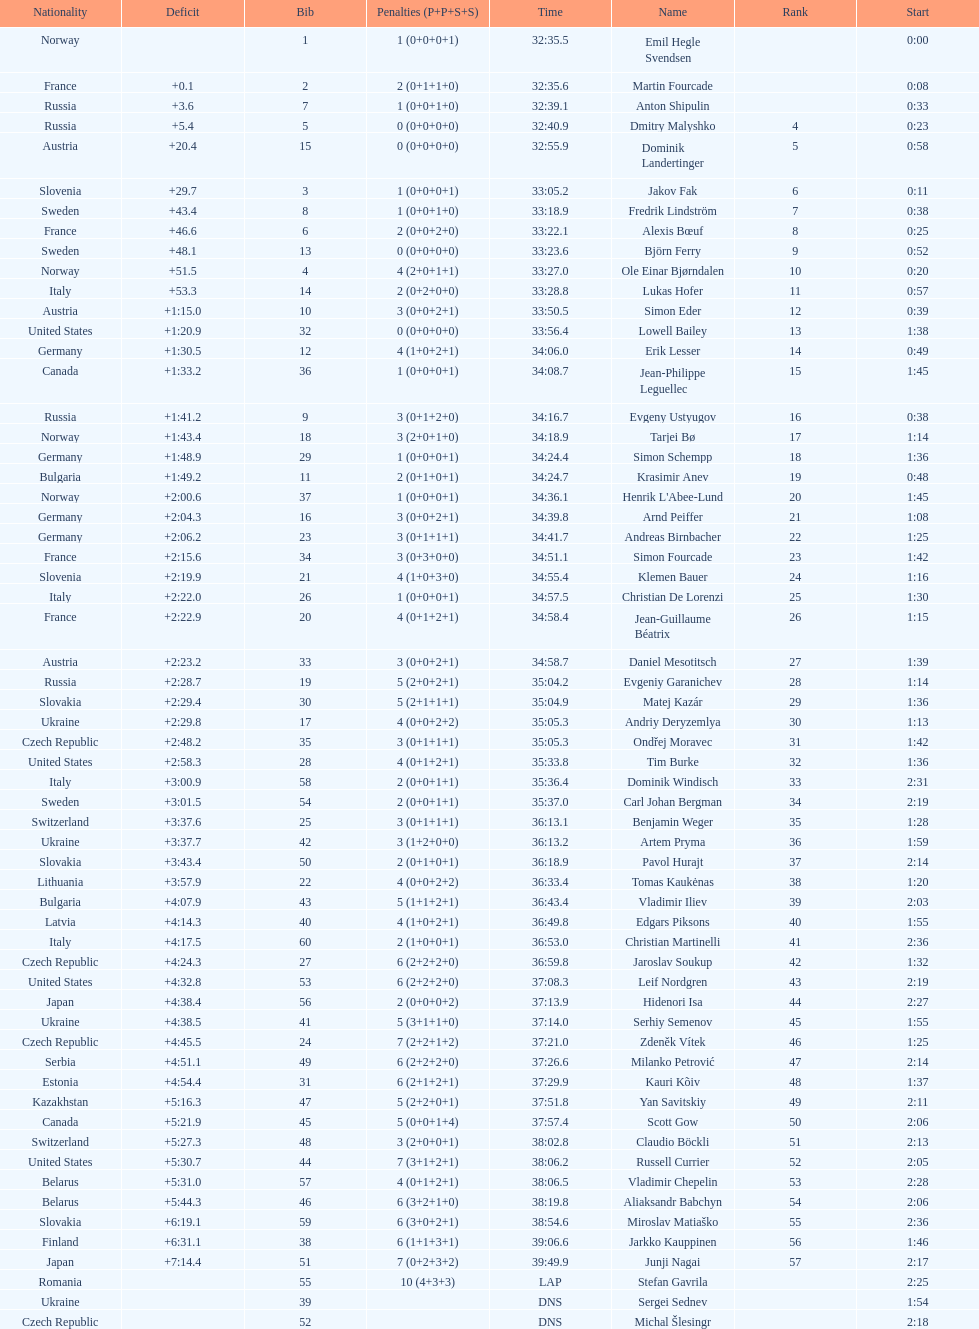What is the largest penalty? 10. 